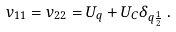<formula> <loc_0><loc_0><loc_500><loc_500>v _ { 1 1 } = v _ { 2 2 } = U _ { q } + U _ { C } \delta _ { q \frac { 1 } { 2 } } \, .</formula> 